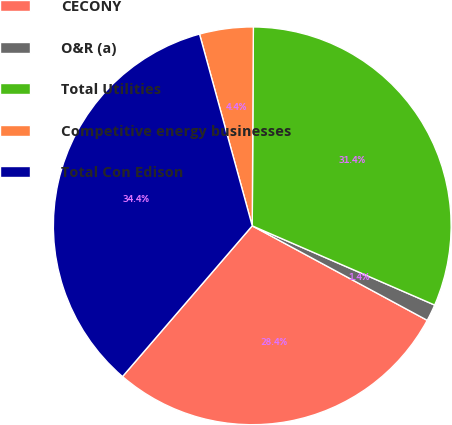Convert chart to OTSL. <chart><loc_0><loc_0><loc_500><loc_500><pie_chart><fcel>CECONY<fcel>O&R (a)<fcel>Total Utilities<fcel>Competitive energy businesses<fcel>Total Con Edison<nl><fcel>28.43%<fcel>1.36%<fcel>31.43%<fcel>4.36%<fcel>34.42%<nl></chart> 